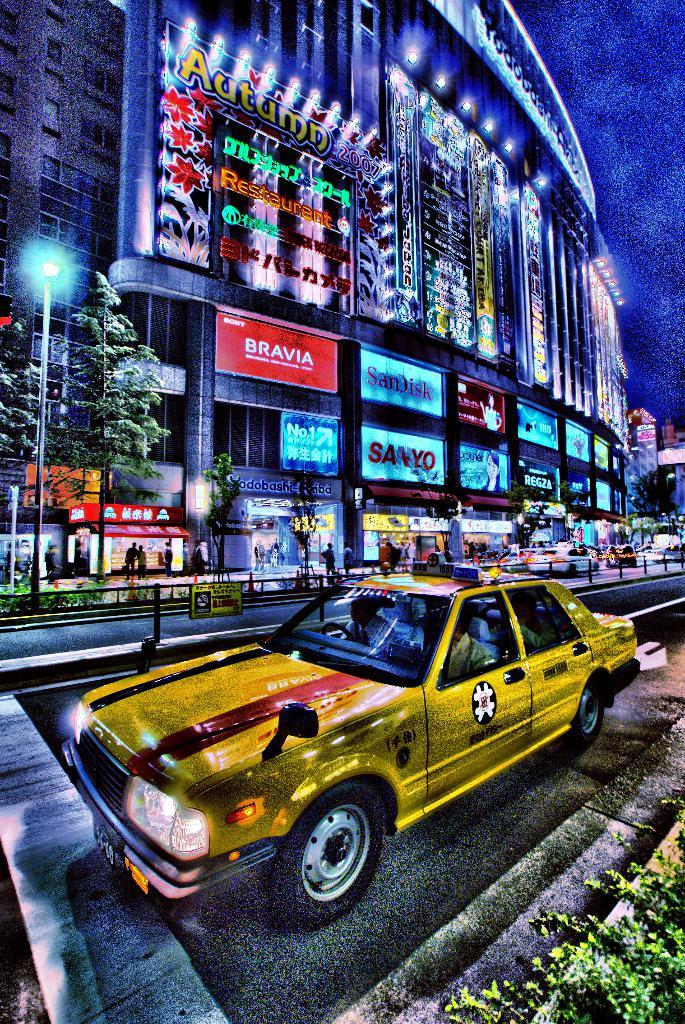What season is mentioned on one of the billboards?
Your answer should be very brief. Autumn. What company is listed on the red sign?
Keep it short and to the point. Bravia. 